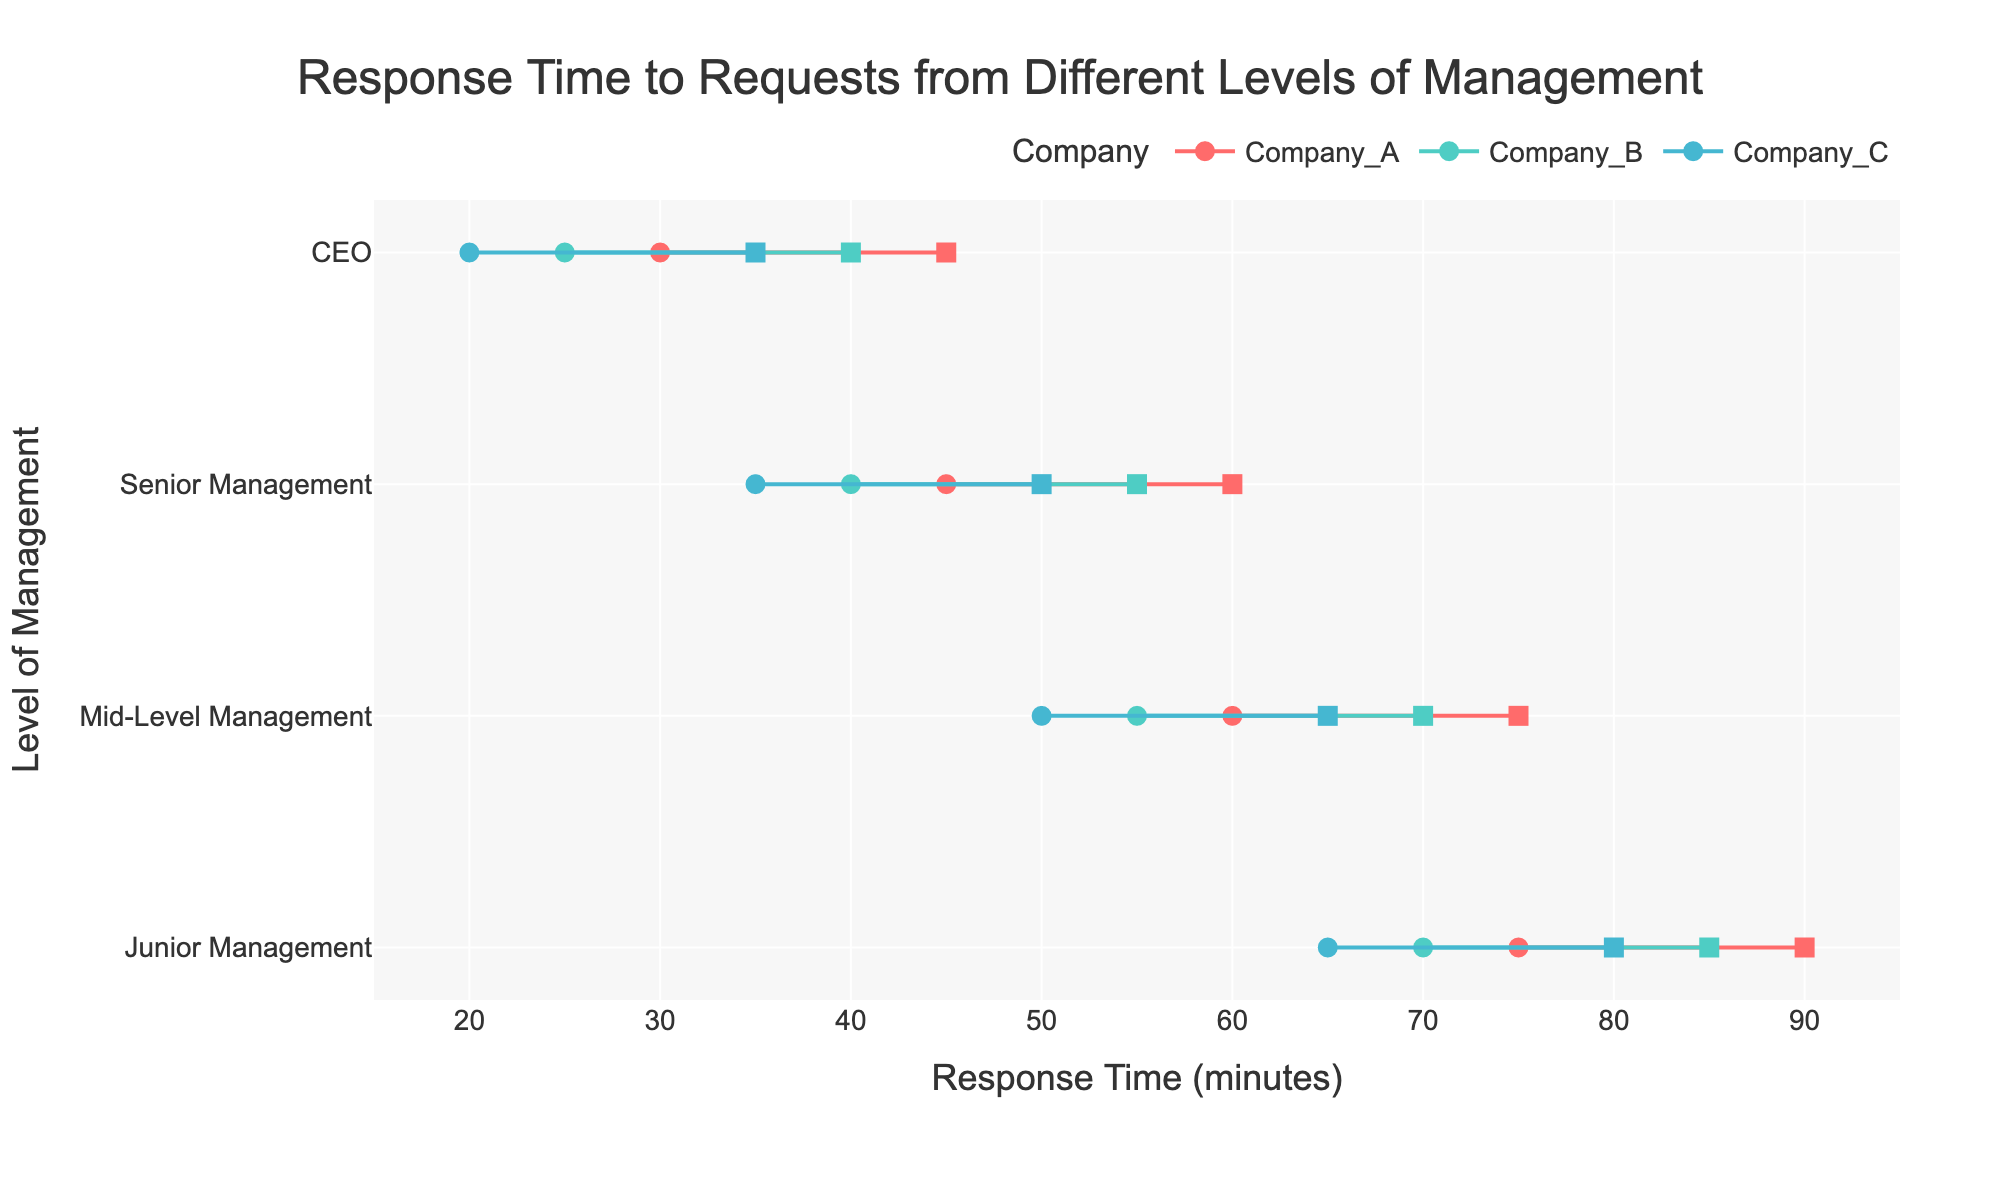What is the title of the figure? The title is typically located at the top of the figure and provides a summary of what the chart represents. In this case, the title is located in the center of the chart's heading area.
Answer: Response Time to Requests from Different Levels of Management What are the response times for the CEOs in Company A? Locate the row corresponding to the CEO level for Company A and read the start and end times. The figure shows these as two points connected by a line.
Answer: 30 to 45 minutes Which level of management shows the longest range of response times in Company B? Check each level of management for Company B and compare the difference between the start and end times. Here, the difference is largest for Junior Management (70 to 85).
Answer: Junior Management What is the average response time range for Senior Management across all companies? First, find the response time ranges for Senior Management in all companies. Calculate the start and end times' averages: (45+40+35)/3 and (60+55+50)/3. Average range is (40, 55).
Answer: 40 to 55 minutes Which company has the smallest range of response times for Mid-Level Management? Calculate the range (end time - start time) for Mid-Level Management in each company. Compare these ranges, and you see Company C has the smallest range (65-50=15).
Answer: Company C How does the response time of Junior Management in Company A compare to the response time of Mid-Level Management in Company B? Find response times of Junior Management in Company A (75 to 90) and Mid-Level Management in Company B (55 to 70). Compare both ranges: Junior Management's times are both larger than Mid-Level's times.
Answer: Junior Management in Company A is longer Which management level has the shortest start response time across all companies? Look at the start times for each management level across all companies and identify the shortest. The shortest start time is for the CEO level in Company C at 20 minutes.
Answer: CEO What is the total response time range for Junior Management across all companies? Add up the start and end times for Junior Management in all companies: start times (75+70+65=210) and end times (90+85+80=255). Total range is (210, 255).
Answer: 210 to 255 minutes Which company has the most consistent response time across different levels of management? You need to find the company with the smallest variation in response times across all management levels. Calculate the range for each level in each company and find the one with the smallest overall range differences.
Answer: Company C Compare the response time ranges of Company A and Company B for Senior Management. Which is wider? Look at the difference between start and end times for Senior Management in both companies: Company A (15) and Company B (15). Both ranges are equal.
Answer: They are the same 